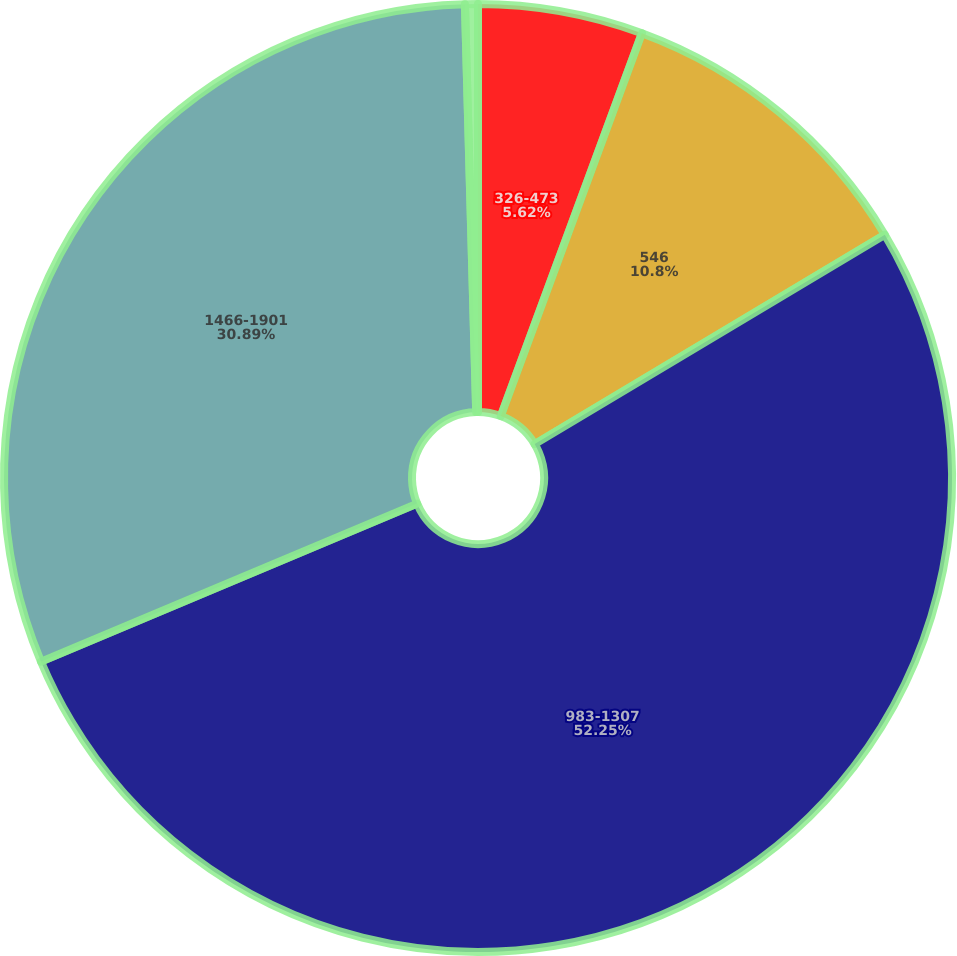<chart> <loc_0><loc_0><loc_500><loc_500><pie_chart><fcel>326-473<fcel>546<fcel>983-1307<fcel>1466-1901<fcel>2090-3458<nl><fcel>5.62%<fcel>10.8%<fcel>52.24%<fcel>30.89%<fcel>0.44%<nl></chart> 